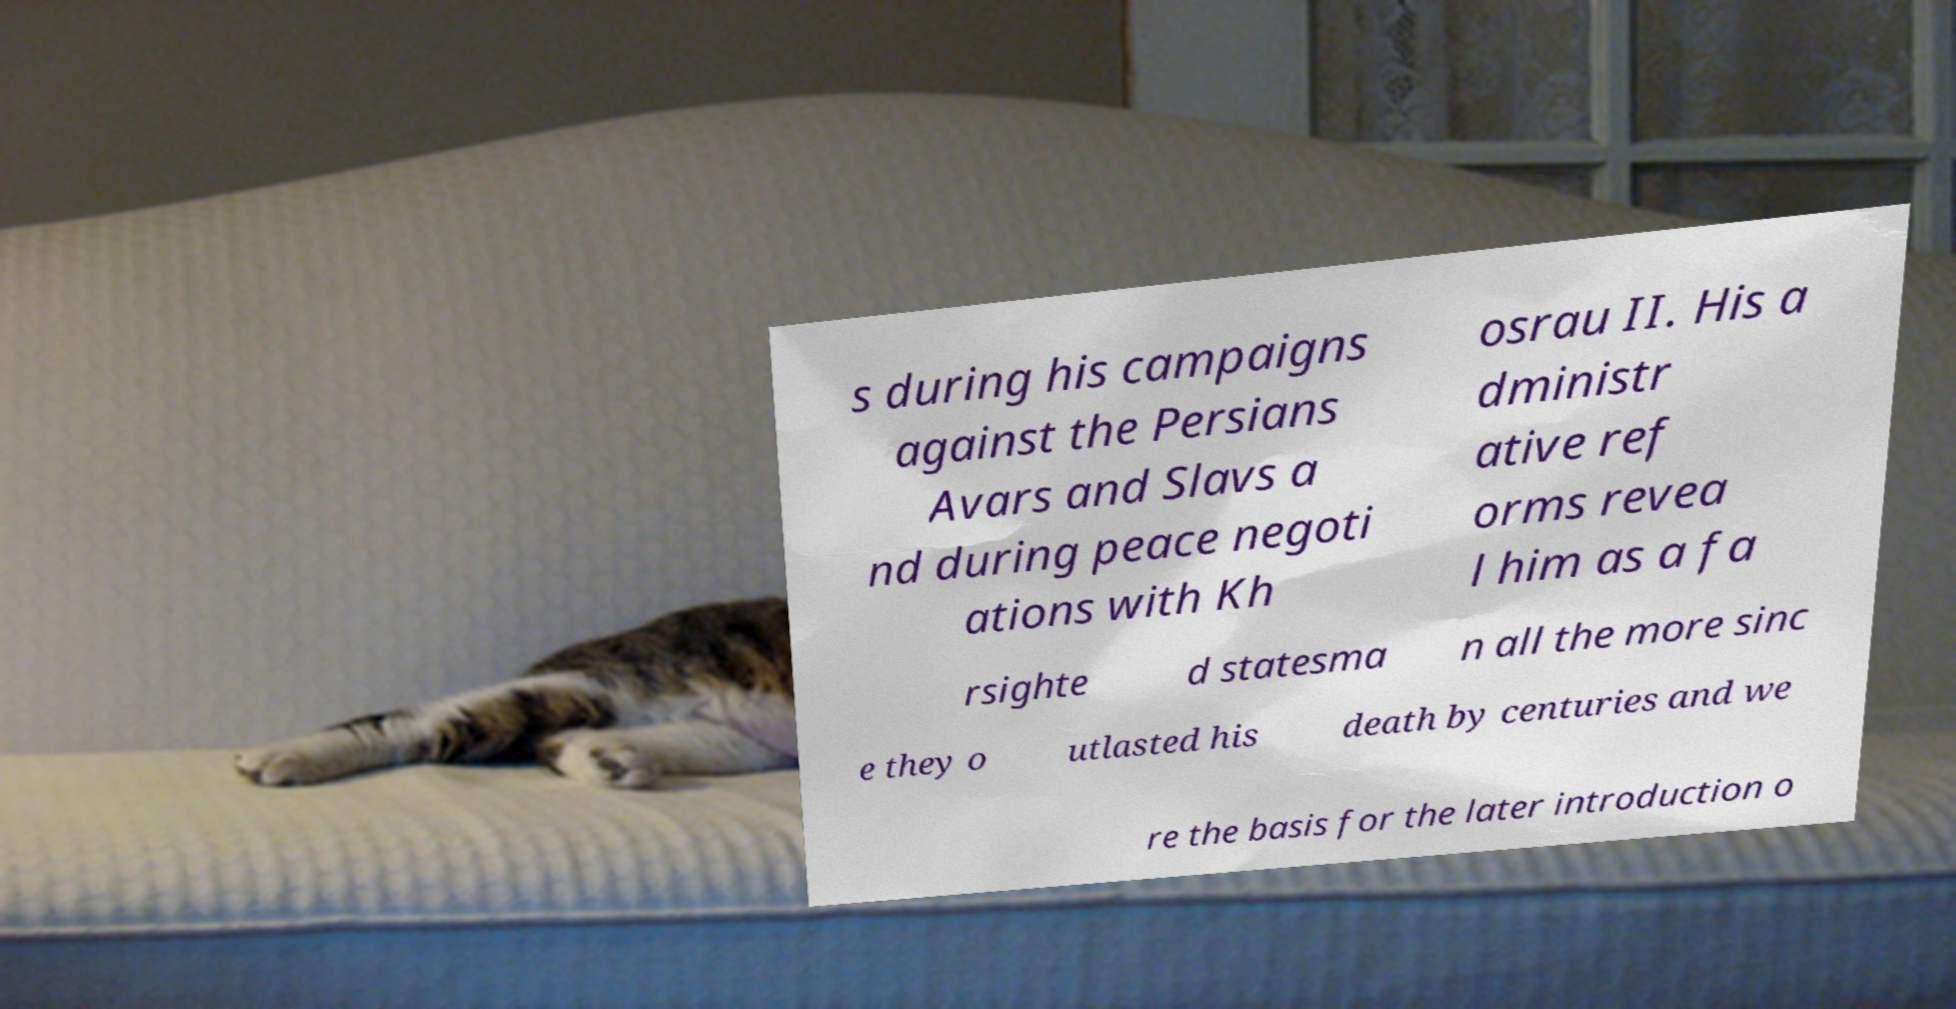Please identify and transcribe the text found in this image. s during his campaigns against the Persians Avars and Slavs a nd during peace negoti ations with Kh osrau II. His a dministr ative ref orms revea l him as a fa rsighte d statesma n all the more sinc e they o utlasted his death by centuries and we re the basis for the later introduction o 